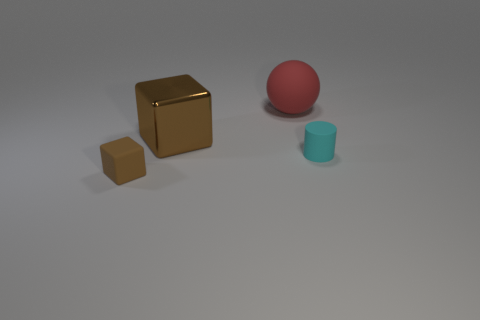Are there the same number of big cubes right of the large brown metallic object and cubes?
Provide a succinct answer. No. Is there a cylinder in front of the object that is right of the red sphere?
Make the answer very short. No. Are there any other things of the same color as the small rubber cylinder?
Your response must be concise. No. Does the small object that is behind the small brown matte thing have the same material as the red ball?
Provide a succinct answer. Yes. Is the number of big metal cubes behind the brown metal cube the same as the number of matte objects in front of the brown matte object?
Ensure brevity in your answer.  Yes. What size is the rubber thing that is on the left side of the brown thing right of the small brown object?
Make the answer very short. Small. There is a object that is both in front of the large brown object and to the right of the brown rubber object; what is it made of?
Offer a very short reply. Rubber. How many other things are the same size as the brown rubber cube?
Your response must be concise. 1. The small matte block is what color?
Your response must be concise. Brown. Do the cube that is behind the matte block and the tiny matte thing to the left of the red matte object have the same color?
Provide a short and direct response. Yes. 